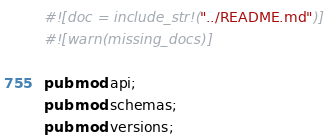Convert code to text. <code><loc_0><loc_0><loc_500><loc_500><_Rust_>#![doc = include_str!("../README.md")]
#![warn(missing_docs)]

pub mod api;
pub mod schemas;
pub mod versions;
</code> 